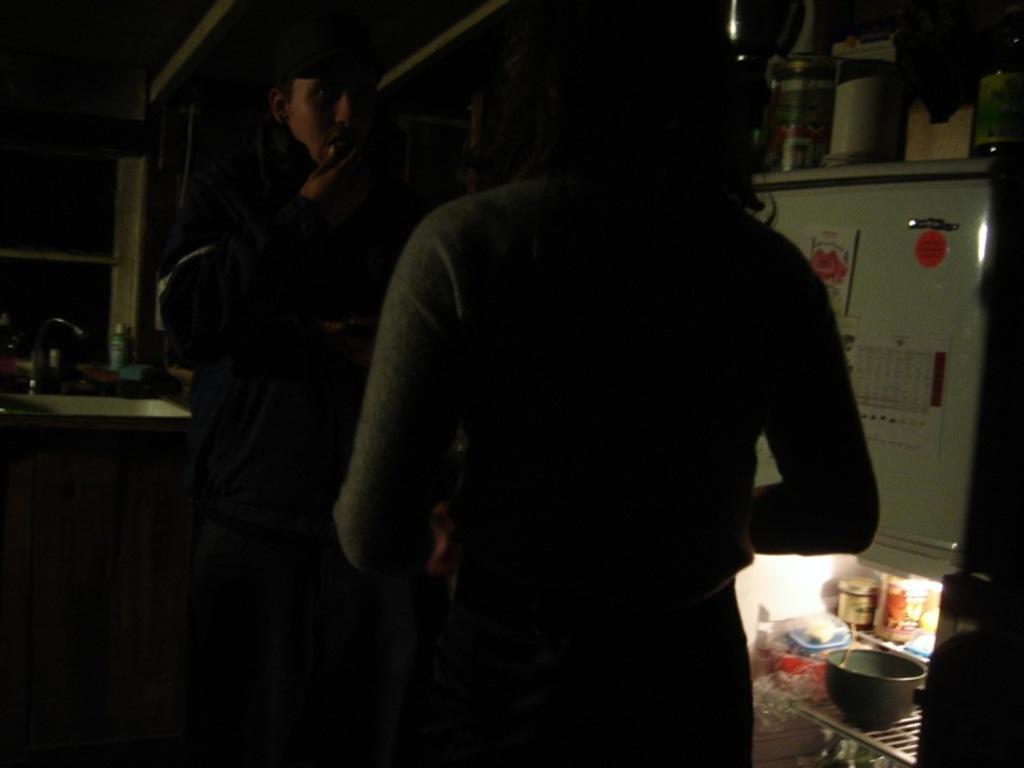Can you describe this image briefly? In the picture we can see a man and a woman standing and facing to each other, man is holding his mouth and beside them, we can see a refrigerator, which is opened and it we can see some bowls, some teens are kept and behind them we can see a sink with a tap and some bottle near it. 